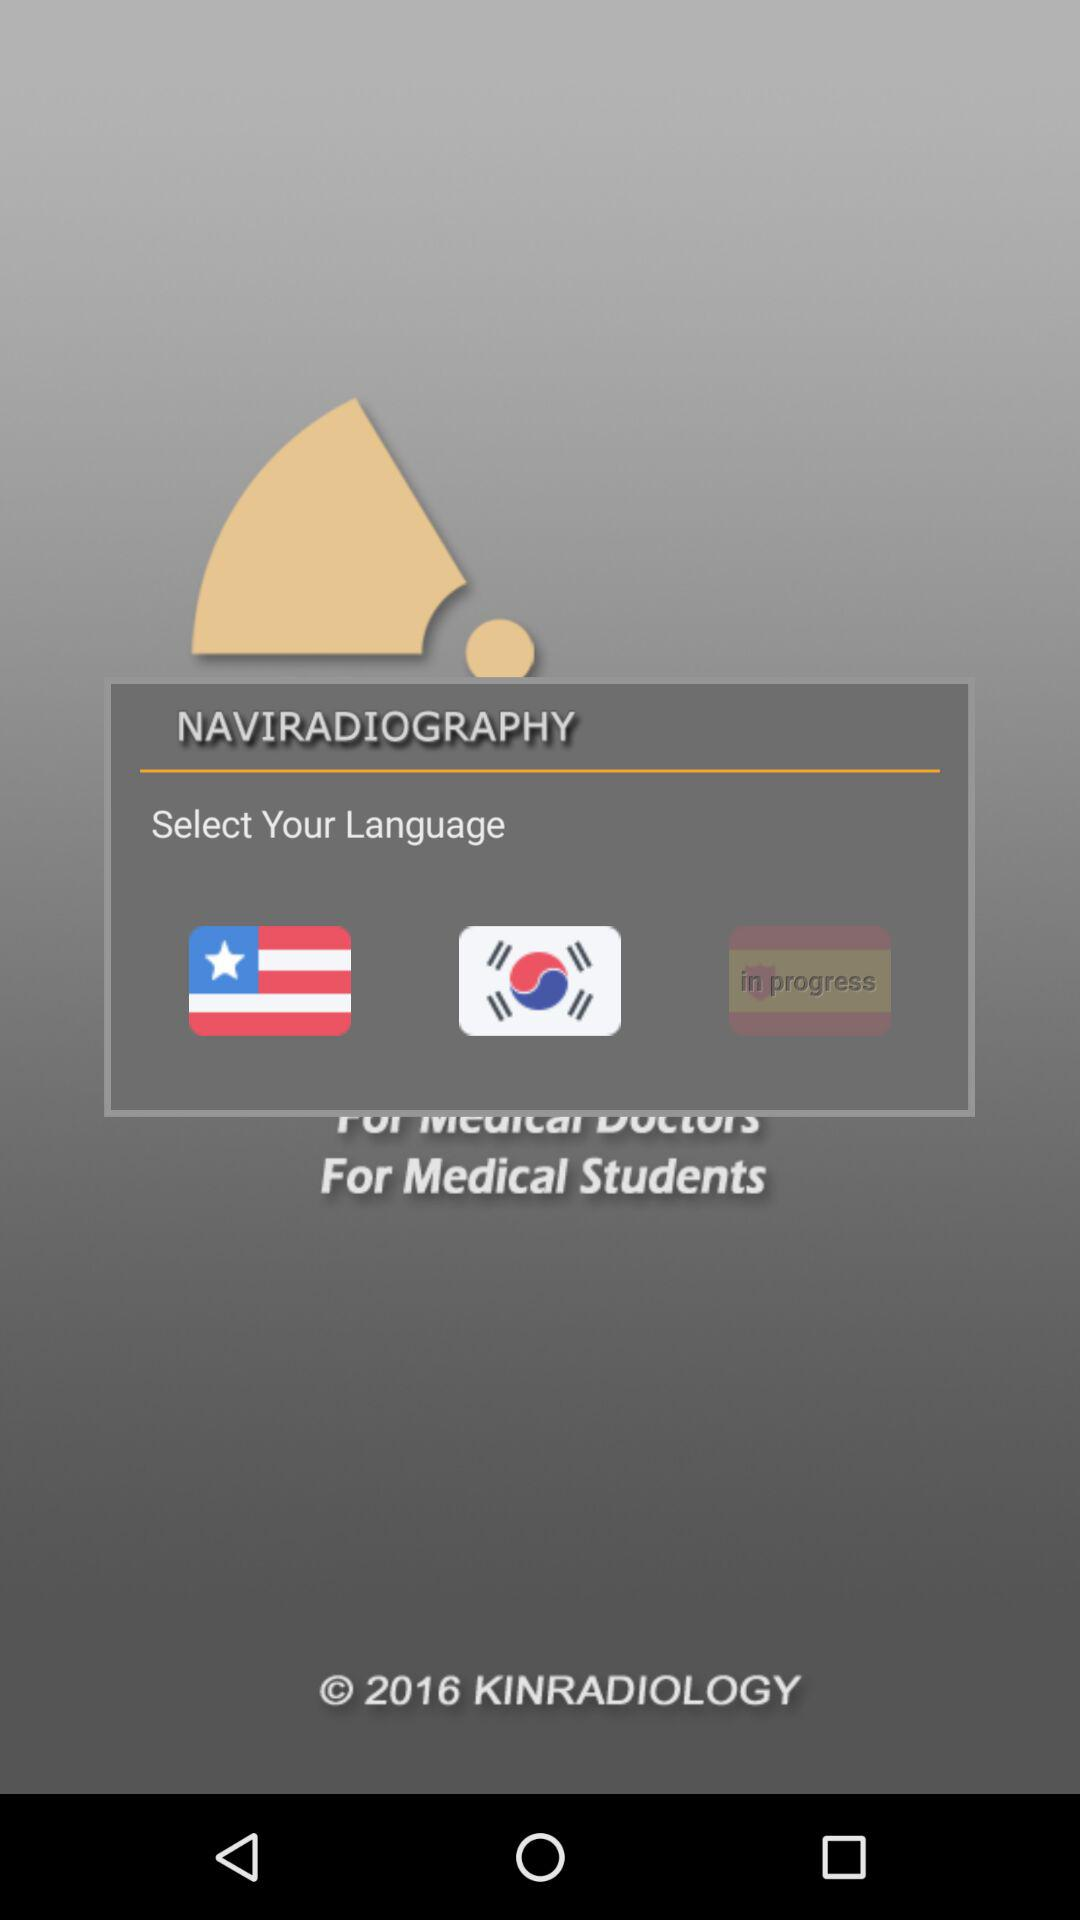How many languages are available to select from?
Answer the question using a single word or phrase. 2 